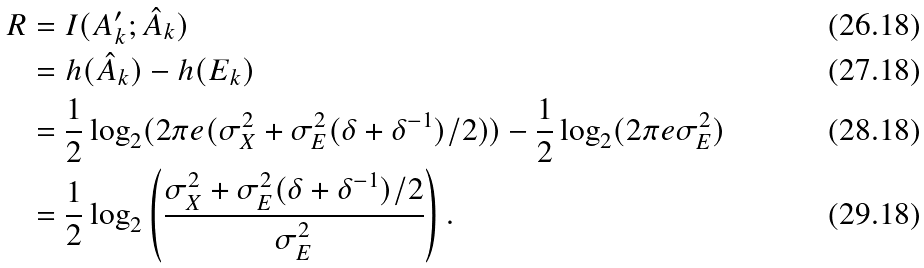Convert formula to latex. <formula><loc_0><loc_0><loc_500><loc_500>R & = I ( A ^ { \prime } _ { k } ; \hat { A } _ { k } ) \\ & = h ( \hat { A } _ { k } ) - h ( E _ { k } ) \\ & = \frac { 1 } { 2 } \log _ { 2 } ( 2 \pi e ( \sigma _ { X } ^ { 2 } + \sigma _ { E } ^ { 2 } ( \delta + \delta ^ { - 1 } ) / 2 ) ) - \frac { 1 } { 2 } \log _ { 2 } ( 2 \pi e \sigma _ { E } ^ { 2 } ) \\ & = \frac { 1 } 2 \log _ { 2 } \left ( \frac { \sigma _ { X } ^ { 2 } + \sigma _ { E } ^ { 2 } ( \delta + \delta ^ { - 1 } ) / 2 } { \sigma _ { E } ^ { 2 } } \right ) .</formula> 